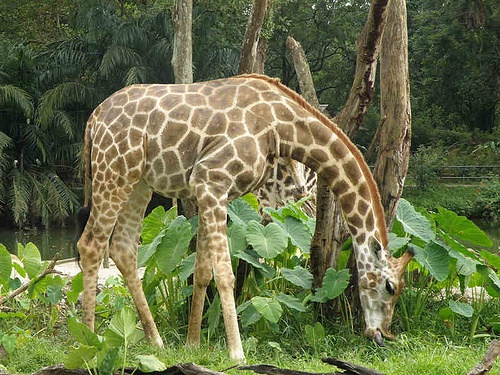Describe the objects in this image and their specific colors. I can see giraffe in darkgreen, tan, and olive tones and giraffe in darkgreen, tan, olive, and gray tones in this image. 